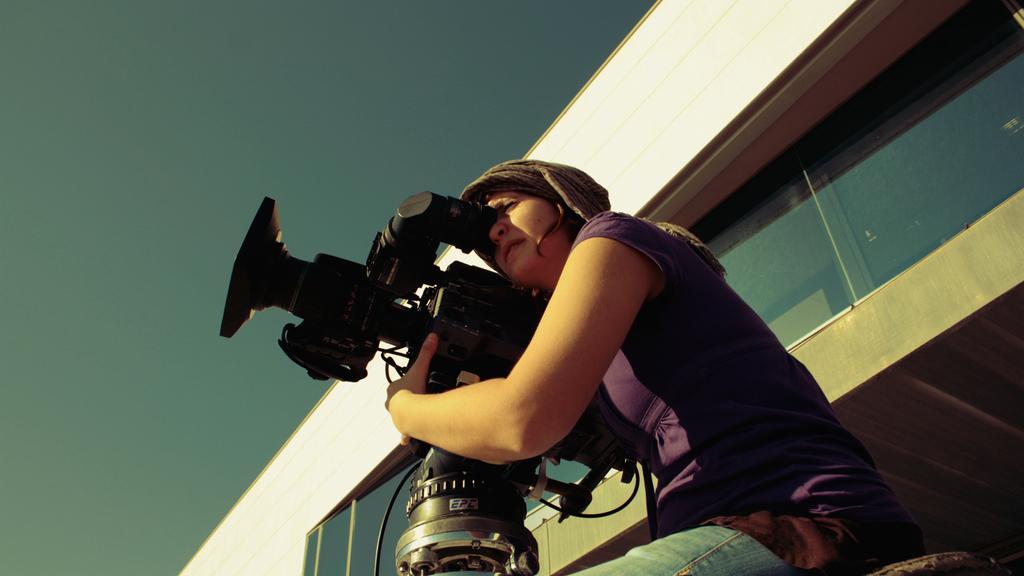Please provide a concise description of this image. A lady with violet t-shirt is sitting. And she is holding a video camera in her hand. Behind her there is a building and a window glass. 